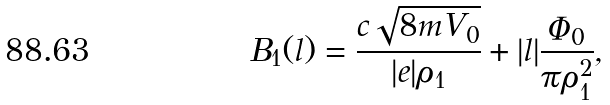<formula> <loc_0><loc_0><loc_500><loc_500>B _ { 1 } ( l ) = \frac { c \sqrt { 8 m V _ { 0 } } } { | e | \rho _ { 1 } } + | l | \frac { \Phi _ { 0 } } { \pi \rho _ { 1 } ^ { 2 } } ,</formula> 